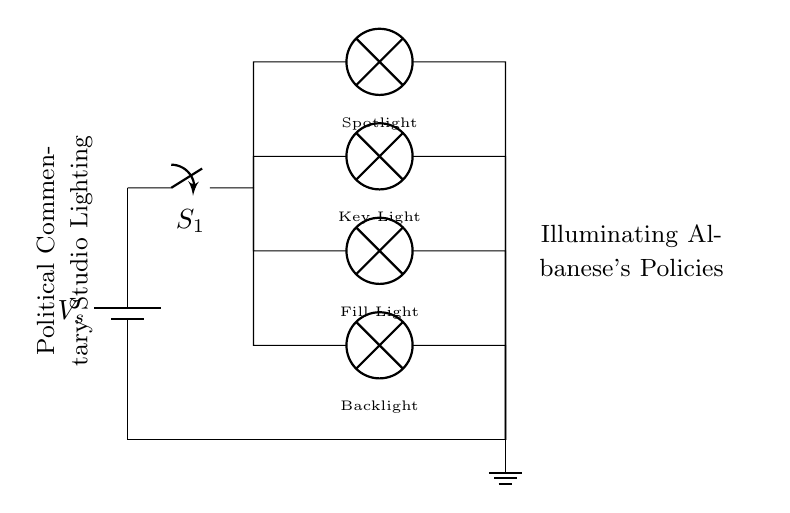What is the total number of lamps in the circuit? The circuit diagram shows four lamps labeled as Spotlight, Key Light, Fill Light, and Backlight. By counting these components, we find there are four lamps in total.
Answer: four What type of connection is used between the lamps? The circuit diagram illustrates that the lamps are wired in parallel. In a parallel configuration, each lamp is connected directly to the power source, allowing them to operate independently.
Answer: parallel What does the switch labeled S1 control? The switch S1 in the diagram controls the flow of electricity from the power source to all the lamps. When S1 is closed, it completes the circuit and allows all lamps to illuminate.
Answer: all lamps How does the circuit ensure redundancy? The parallel design of the circuit provides redundancy; if one lamp fails or is removed, the others continue to receive power and light up. This feature is a significant advantage of parallel circuits compared to series circuits, where one failure would break the entire circuit.
Answer: redundancy What is the function of the battery in the circuit? The battery in this diagram acts as the power source, providing the necessary electrical energy to power all lamps in the parallel circuit. The voltage from the battery drives the lights, allowing them to illuminate the studio effectively.
Answer: power source 